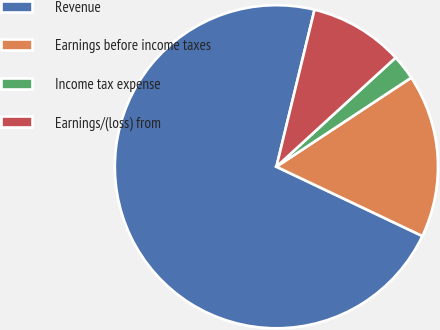<chart> <loc_0><loc_0><loc_500><loc_500><pie_chart><fcel>Revenue<fcel>Earnings before income taxes<fcel>Income tax expense<fcel>Earnings/(loss) from<nl><fcel>71.74%<fcel>16.35%<fcel>2.5%<fcel>9.42%<nl></chart> 